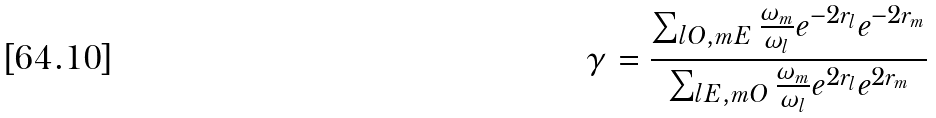Convert formula to latex. <formula><loc_0><loc_0><loc_500><loc_500>\gamma = \frac { \sum _ { l O , m E } \frac { \omega _ { m } } { \omega _ { l } } e ^ { - 2 r _ { l } } e ^ { - 2 r _ { m } } } { \sum _ { l E , m O } \frac { \omega _ { m } } { \omega _ { l } } e ^ { 2 r _ { l } } e ^ { 2 r _ { m } } }</formula> 